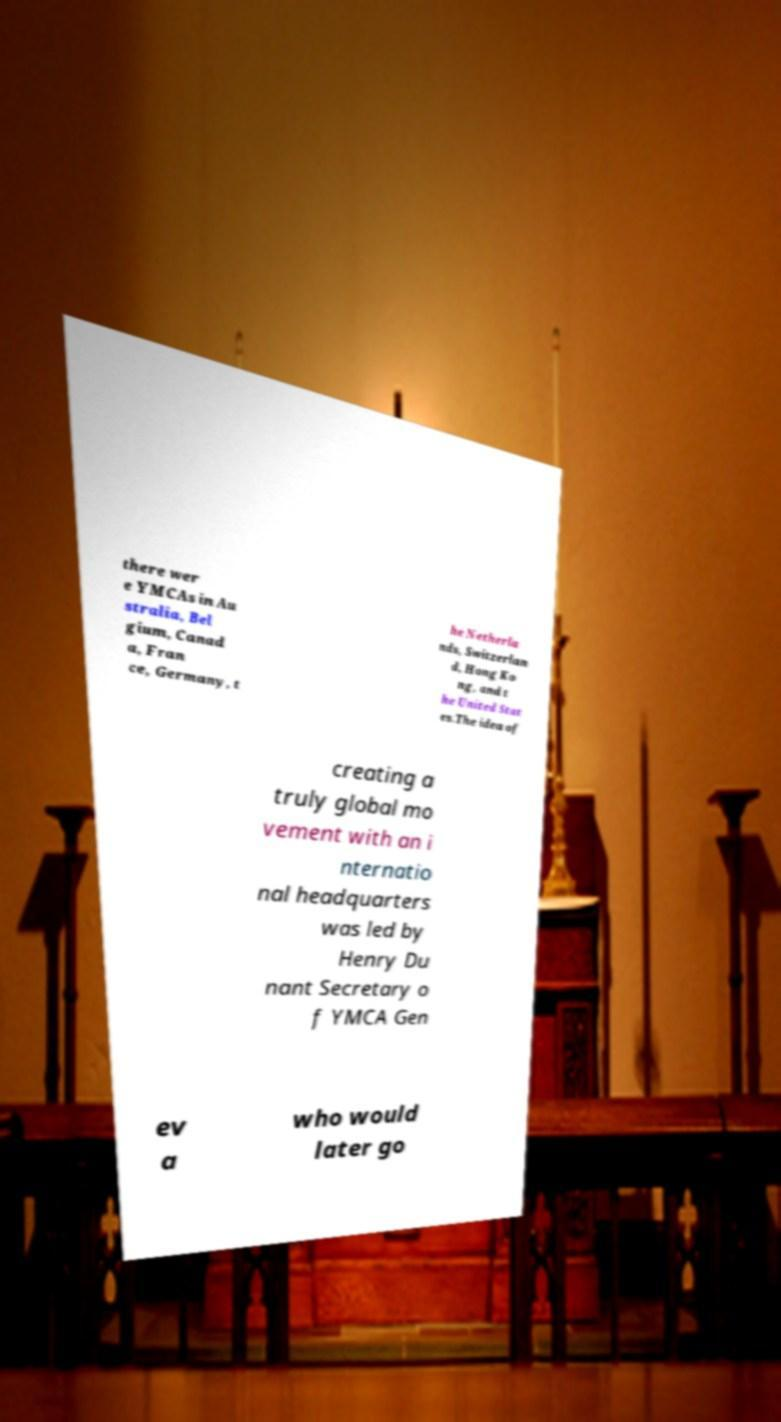For documentation purposes, I need the text within this image transcribed. Could you provide that? there wer e YMCAs in Au stralia, Bel gium, Canad a, Fran ce, Germany, t he Netherla nds, Switzerlan d, Hong Ko ng, and t he United Stat es.The idea of creating a truly global mo vement with an i nternatio nal headquarters was led by Henry Du nant Secretary o f YMCA Gen ev a who would later go 